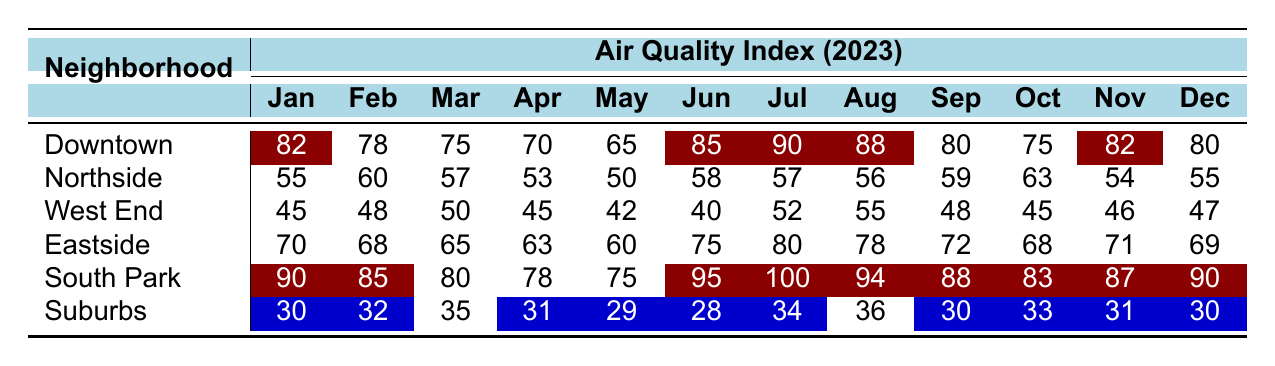What is the air quality index in South Park for July? The table shows that the air quality index in South Park for July is listed under the July column, which is 100.
Answer: 100 Which neighborhood had the best air quality index in January? By examining the January column, South Park has the highest value at 90, compared to other neighborhoods.
Answer: South Park What is the average air quality index for Northside from January to December? To find the average, sum all monthly values for Northside (55 + 60 + 57 + 53 + 50 + 58 + 57 + 56 + 59 + 63 + 54 + 55 = 670) and divide by 12. The average is 670 / 12 = 55.83.
Answer: 55.83 Was the air quality index for West End ever below 50 in 2023? By looking at the table, the lowest value for West End is 40 in June, which is below 50. Therefore, the statement is true.
Answer: Yes What is the difference in air quality index between Eastside in July and the average of Suburbs for the same month? The July value for Eastside is 80 and for Suburbs is 34. The difference is 80 - 34 = 46.
Answer: 46 Which neighborhood consistently had the lowest air quality index from January to December? Examining the data across all months, Suburbs has the lowest values consistently, with no month showing a higher index than 36.
Answer: Suburbs What is the highest air quality index recorded in Downtown during 2023? The highest value for Downtown found in the table is 90 in July.
Answer: 90 How many neighborhoods had an air quality index above 80 in October? In October, the neighborhoods with indices above 80 are Downtown at 75, South Park at 83. Only South Park meets the criteria, so there is one neighborhood.
Answer: 1 What is the total air quality index for South Park from January to December? By summing all months: (90 + 85 + 80 + 78 + 75 + 95 + 100 + 94 + 88 + 83 + 87 + 90 = 1036).
Answer: 1036 Are there any months when Eastside had a lower air quality index than Northside? In the table, reviewing values reveals that Eastside is lower than Northside in April (63 < 53), making this statement true.
Answer: Yes 